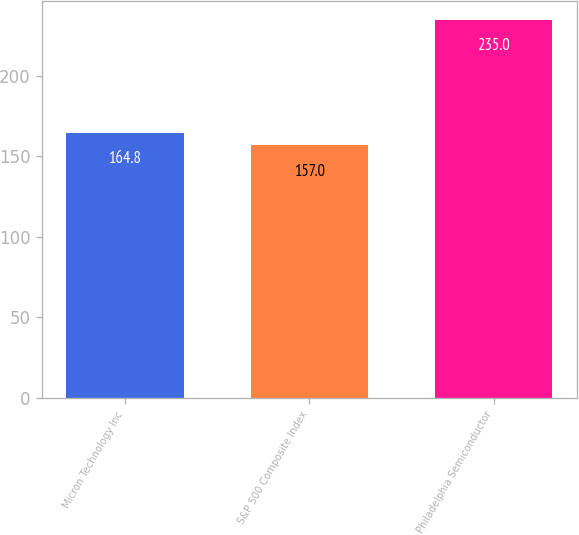<chart> <loc_0><loc_0><loc_500><loc_500><bar_chart><fcel>Micron Technology Inc<fcel>S&P 500 Composite Index<fcel>Philadelphia Semiconductor<nl><fcel>164.8<fcel>157<fcel>235<nl></chart> 